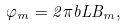Convert formula to latex. <formula><loc_0><loc_0><loc_500><loc_500>\varphi _ { m } = 2 \pi b L B _ { m } ,</formula> 